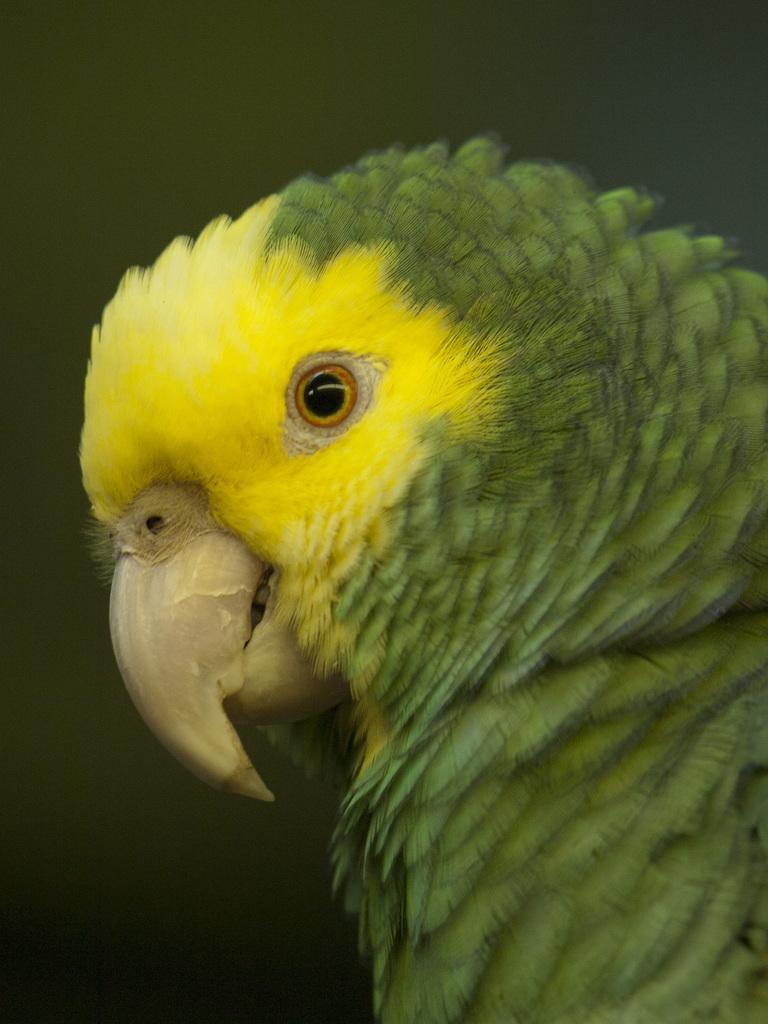Describe this image in one or two sentences. Here in this picture we can see a budgerigar present over there. 